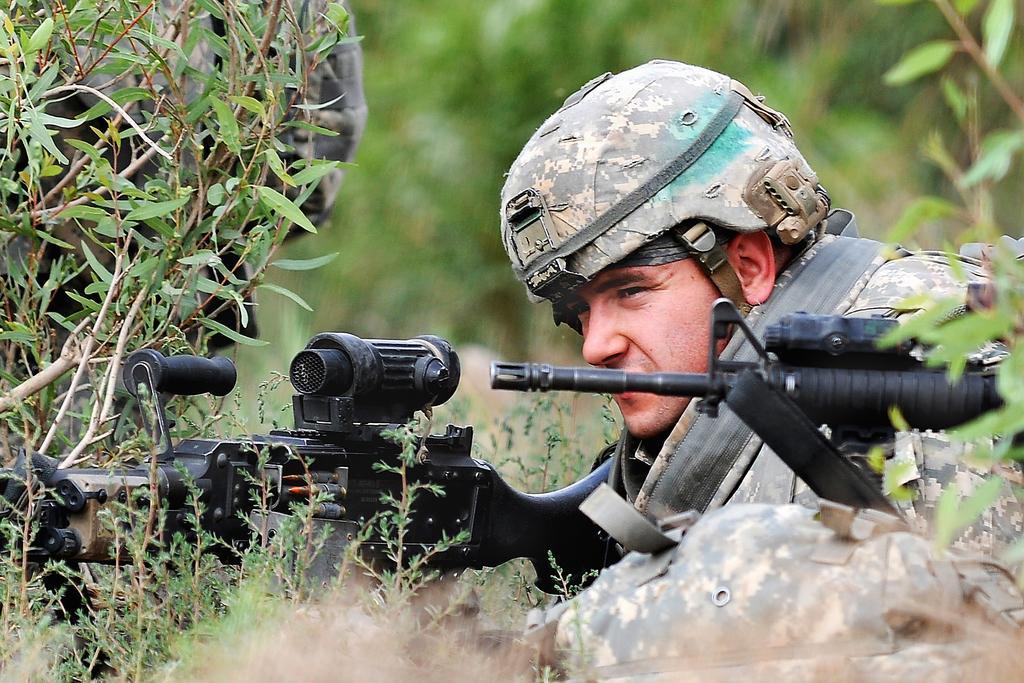Can you describe this image briefly? In this picture there is an army officer who is wearing helmet and shirt. He is holding a machine gun, beside him I can see another gun and bag. In the top left I can see the person near to the plant. In the background I can see the trees and blur image. 